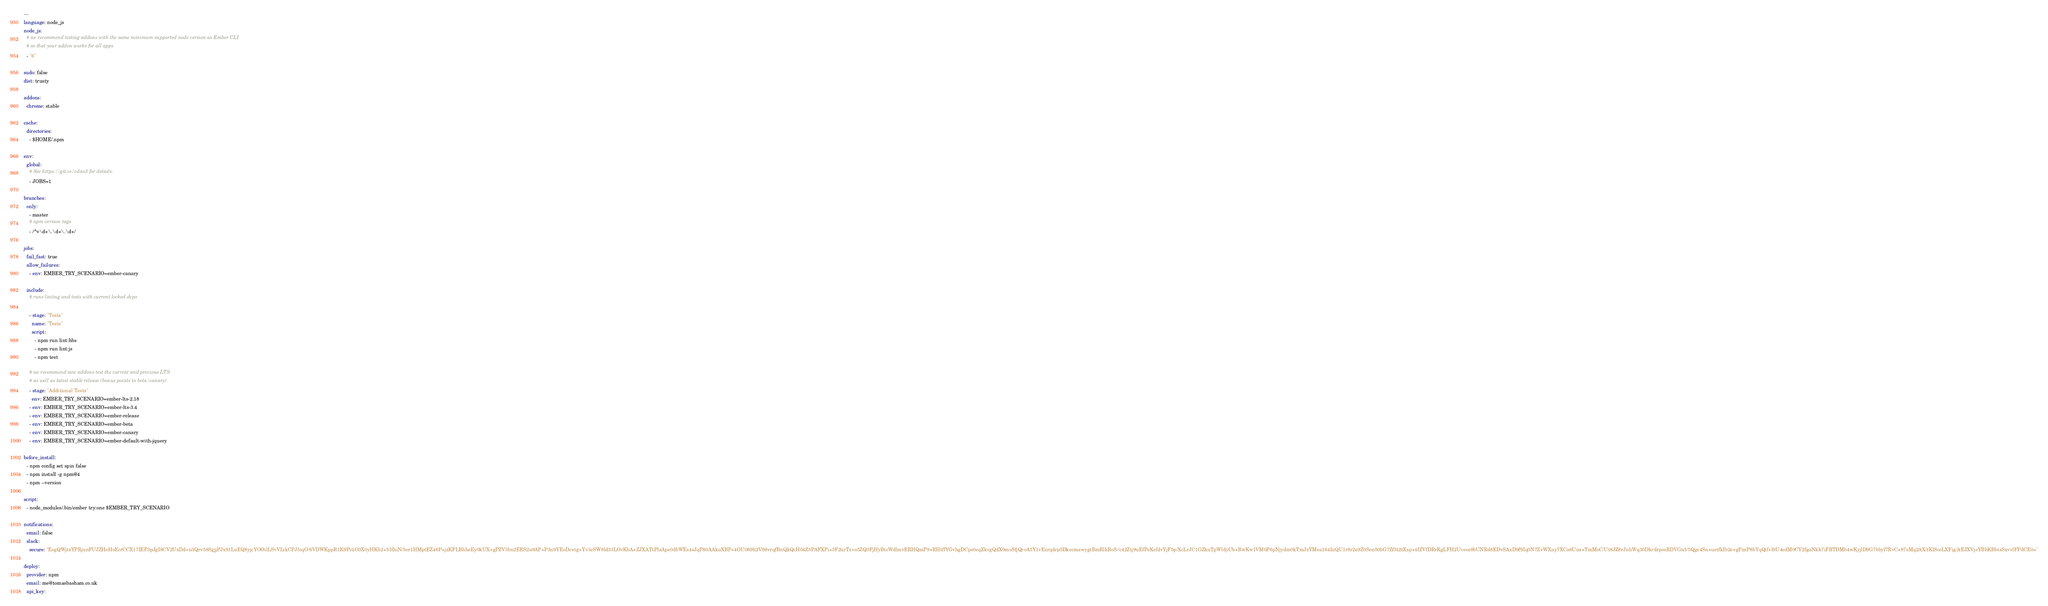<code> <loc_0><loc_0><loc_500><loc_500><_YAML_>---
language: node_js
node_js:
  # we recommend testing addons with the same minimum supported node version as Ember CLI
  # so that your addon works for all apps
  - "6"

sudo: false
dist: trusty

addons:
  chrome: stable

cache:
  directories:
    - $HOME/.npm

env:
  global:
    # See https://git.io/vdao3 for details.
    - JOBS=1

branches:
  only:
    - master
    # npm version tags
    - /^v\d+\.\d+\.\d+/

jobs:
  fail_fast: true
  allow_failures:
    - env: EMBER_TRY_SCENARIO=ember-canary

  include:
    # runs linting and tests with current locked deps

    - stage: "Tests"
      name: "Tests"
      script:
        - npm run lint:hbs
        - npm run lint:js
        - npm test

    # we recommend new addons test the current and previous LTS
    # as well as latest stable release (bonus points to beta/canary)
    - stage: "Additional Tests"
      env: EMBER_TRY_SCENARIO=ember-lts-2.18
    - env: EMBER_TRY_SCENARIO=ember-lts-3.4
    - env: EMBER_TRY_SCENARIO=ember-release
    - env: EMBER_TRY_SCENARIO=ember-beta
    - env: EMBER_TRY_SCENARIO=ember-canary
    - env: EMBER_TRY_SCENARIO=ember-default-with-jquery

before_install:
  - npm config set spin false
  - npm install -g npm@4
  - npm --version

script:
  - node_modules/.bin/ember try:one $EMBER_TRY_SCENARIO

notifications:
  email: false
  slack:
    secure: "EogQWjtzYPRjunFUJZHeHoEcrCCX17IEF3pJgI8CV2UxDd+n3Qrv58SgjjPJx91LuEQ8yjcYOOilLSvVLikCPJ5iqO/6VDWKppR1K9PitiO3X0yHKb2+53lhiN/5er1HMptEZ46P+jzKFLBhheEy0kUX+gPZV3bn2EES2a9AP+P3n9YEoDc+tg+Yv/ieSW8ld33LOvKbA+ZJXATtPlaAps0dbWEs4sJqP80AAkuXBP+4OU089h2V96vrqfBnQkQcH04Z5PAFXPi+3F2urTz+o5ZQ0FjHyBtcWdlmvERHQmP9+RHtffYGvhgDCps0eqZkvgQdX0moSfjQroA5Y1vEzrqdrp5DkecmawygtBmRlkRoS//c42Ztj9uEfPeKcfdvYjF5p/XcLrJC1GZkuTpWldyUb+RwKw1VM0P6pNjydm0kTmJzYMea164IuQU1r8r2e9Z0Sen50bG7Zf3t2tXsp+4IZVfDRrKgLFH2Uveoe8bUNRd8EDvSAxD9f9Iq0N7Z+WXny7XCa6Uux+TmMoC/Ut8JZ8rJnhWq30DkrdrpoeRDVGn3/5Qgc4Sn+uetfkIb2e+gPzxP8bYqQif+l9U4edM0CY2fgaNkk7iFBTDMb4wKyjlD9G7bbyf7RvC+87sMq2AX/tKlSceLXFig/AEJXVjeYBbKBbtsSxvvlFPdCE0="

deploy:
  provider: npm
  email: me@tomasbasham.co.uk
  api_key:</code> 